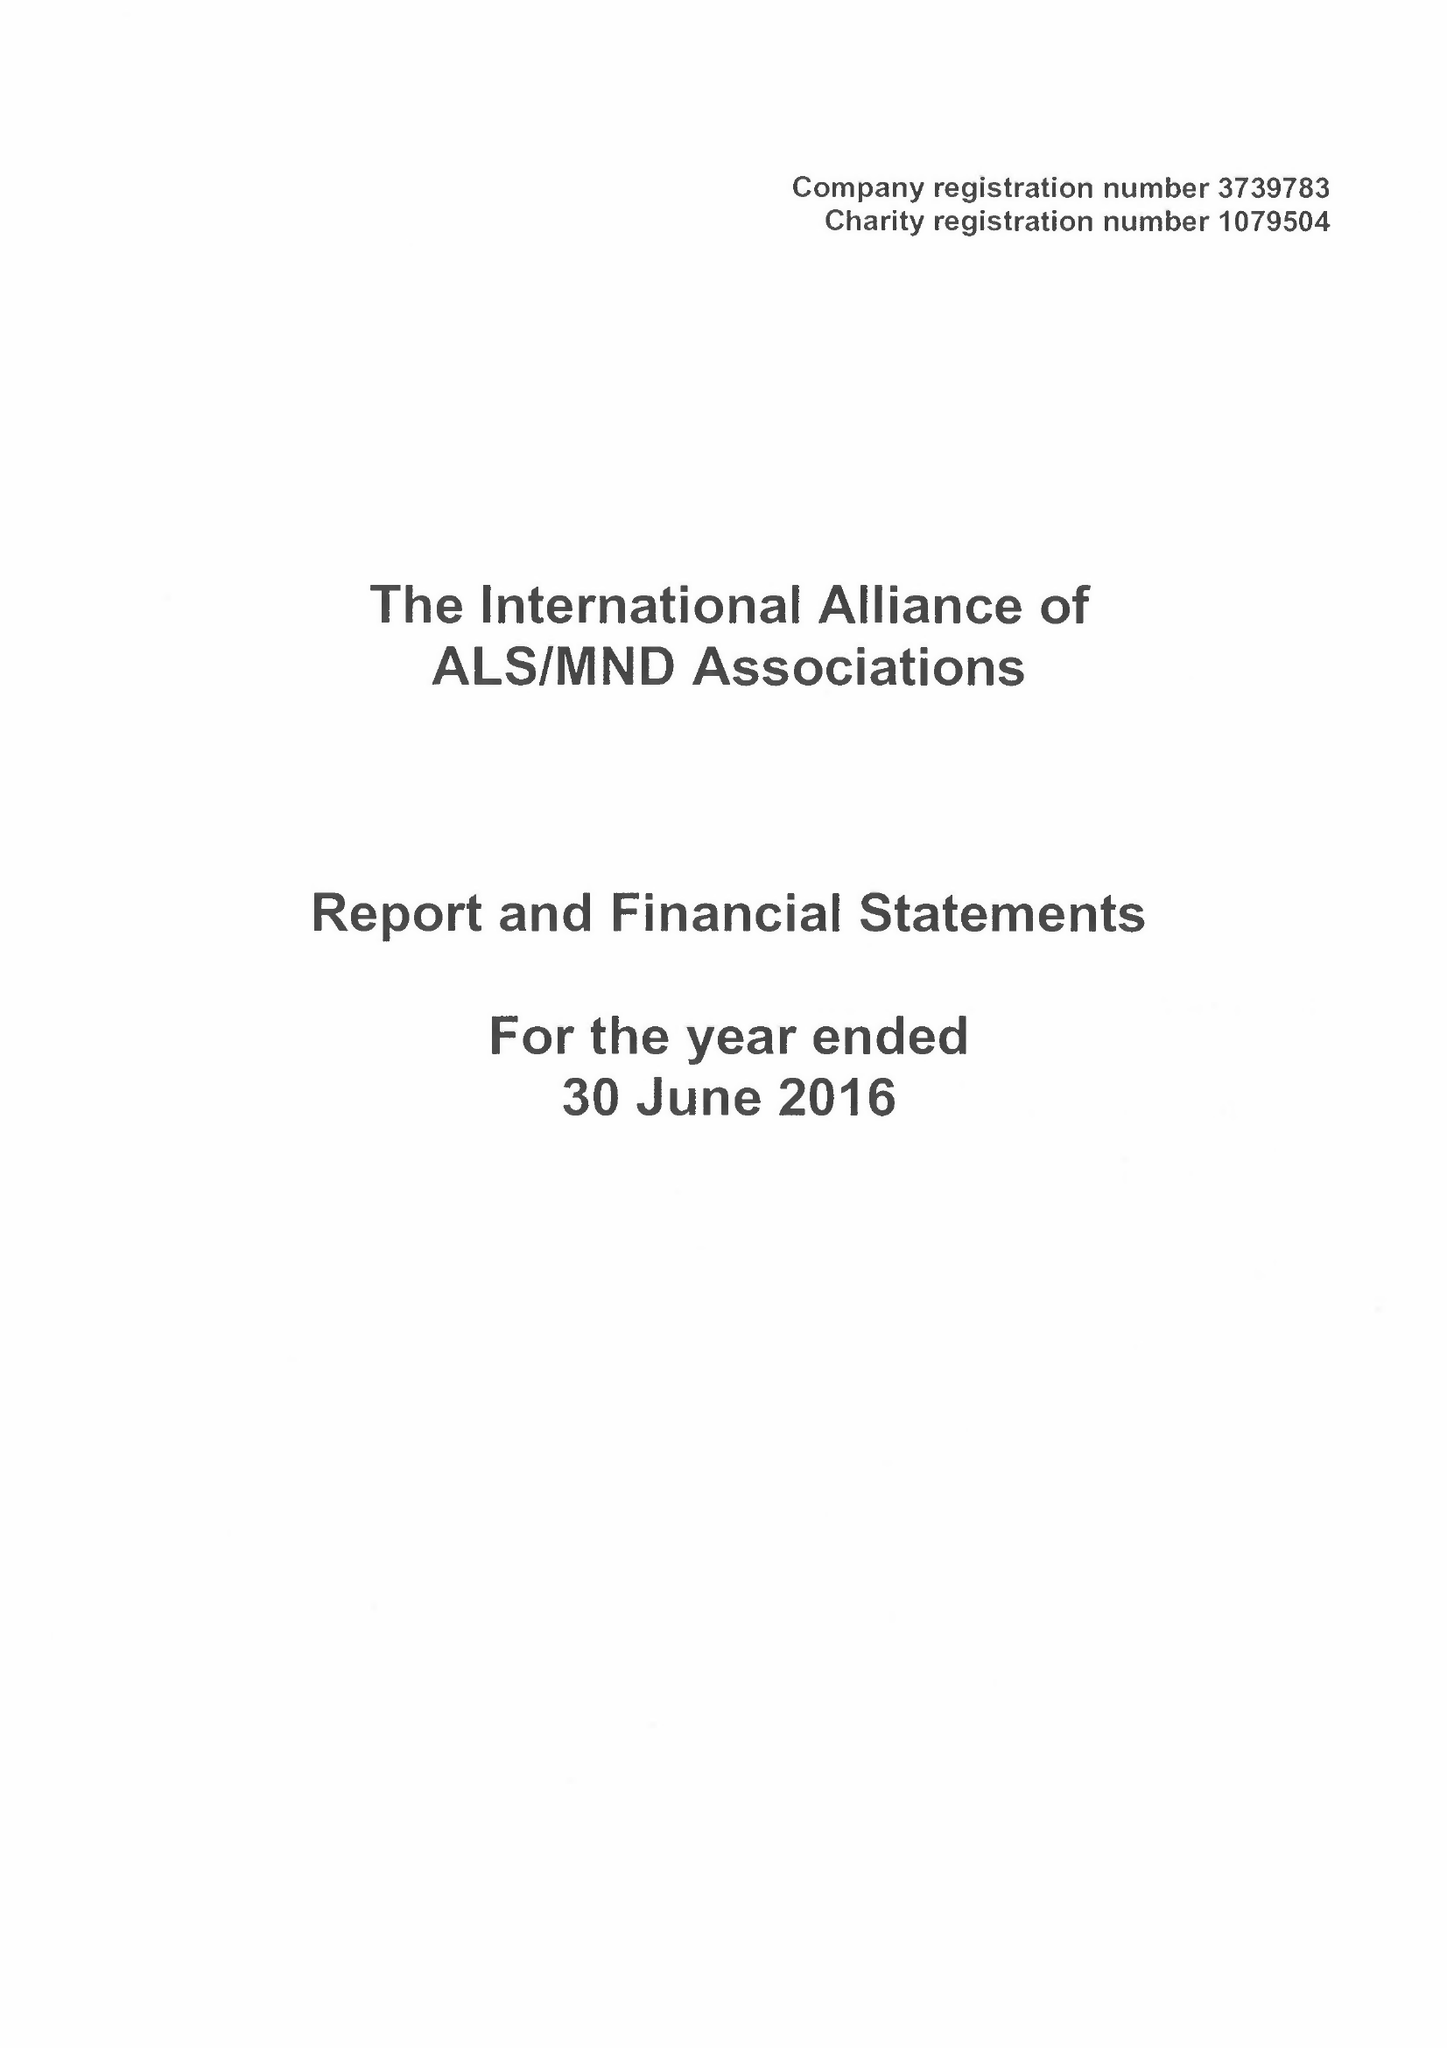What is the value for the charity_number?
Answer the question using a single word or phrase. 1079504 